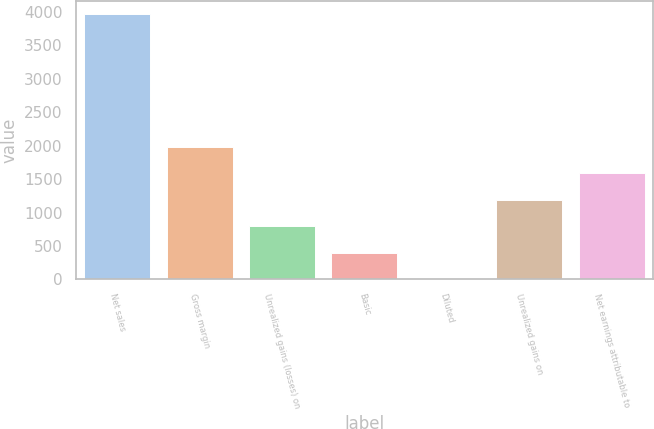Convert chart to OTSL. <chart><loc_0><loc_0><loc_500><loc_500><bar_chart><fcel>Net sales<fcel>Gross margin<fcel>Unrealized gains (losses) on<fcel>Basic<fcel>Diluted<fcel>Unrealized gains on<fcel>Net earnings attributable to<nl><fcel>3965<fcel>1985.19<fcel>797.28<fcel>401.31<fcel>5.34<fcel>1193.25<fcel>1589.22<nl></chart> 